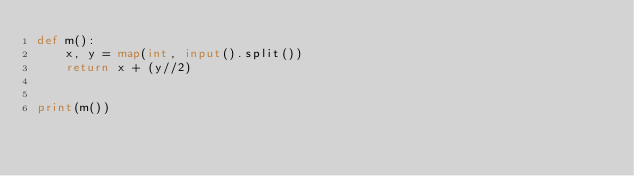Convert code to text. <code><loc_0><loc_0><loc_500><loc_500><_Python_>def m():
    x, y = map(int, input().split())
    return x + (y//2)
    

print(m())</code> 